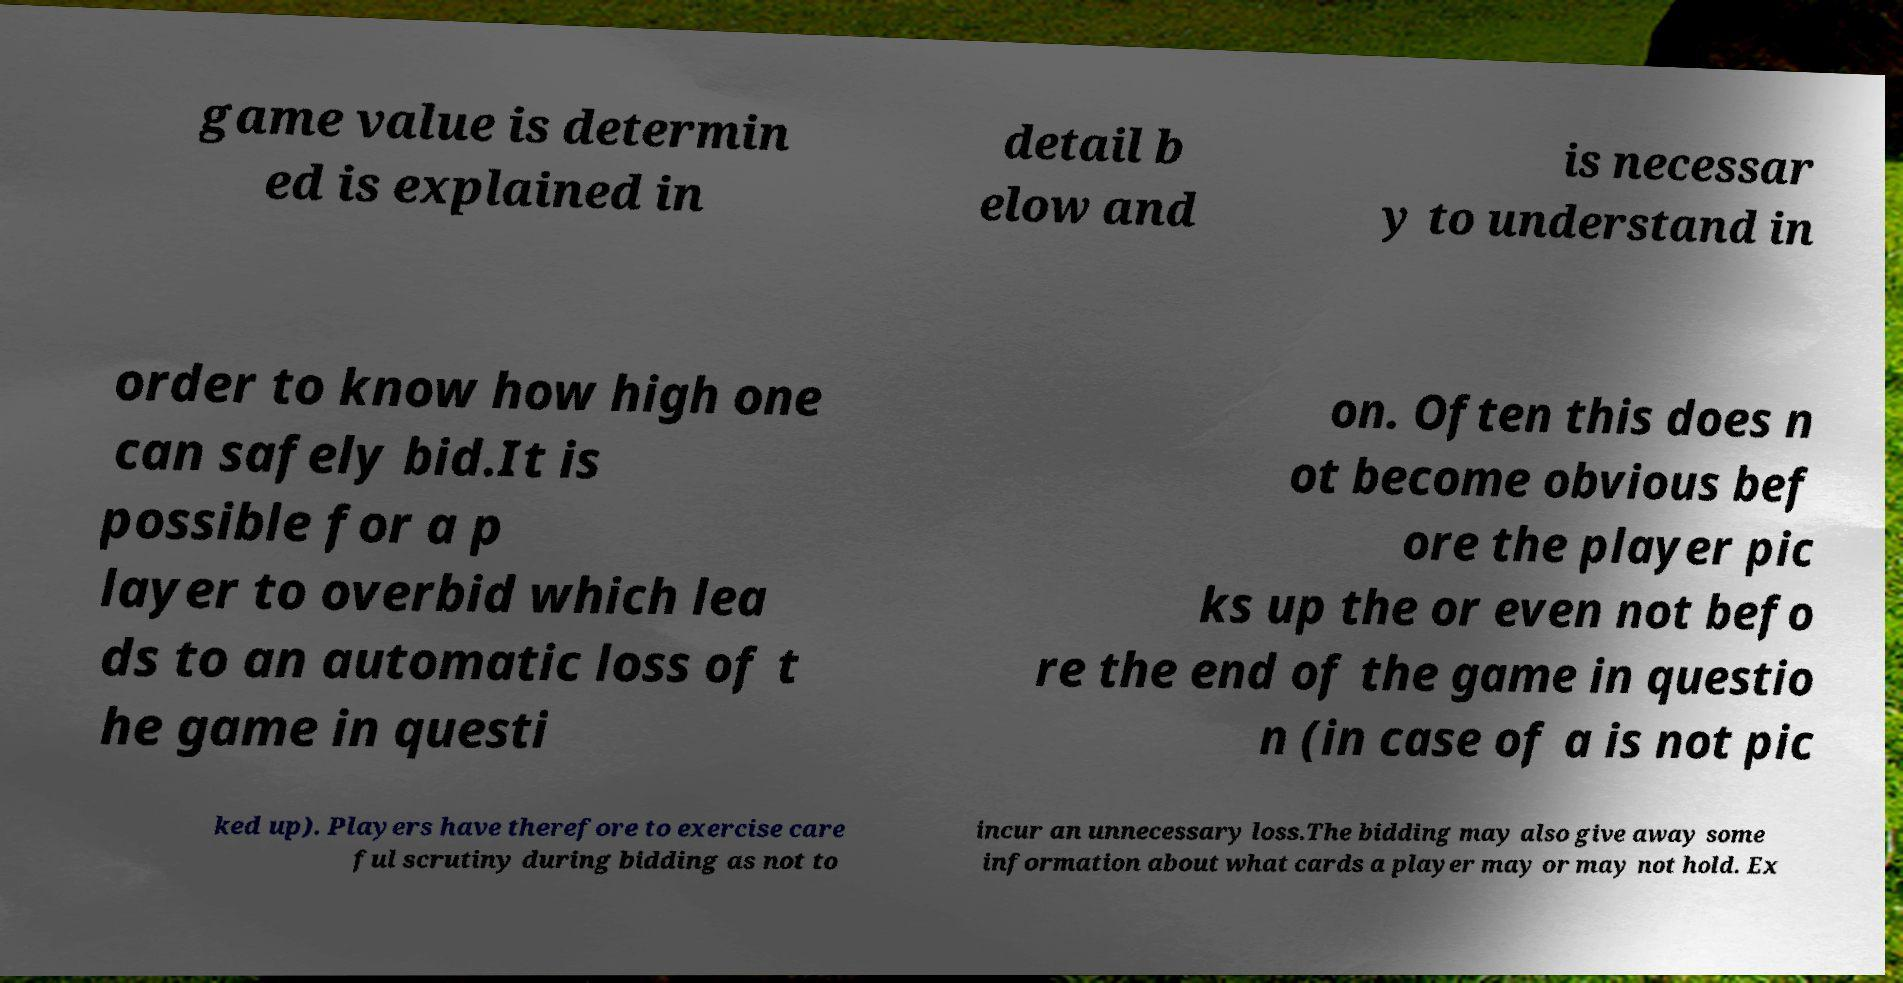Please read and relay the text visible in this image. What does it say? game value is determin ed is explained in detail b elow and is necessar y to understand in order to know how high one can safely bid.It is possible for a p layer to overbid which lea ds to an automatic loss of t he game in questi on. Often this does n ot become obvious bef ore the player pic ks up the or even not befo re the end of the game in questio n (in case of a is not pic ked up). Players have therefore to exercise care ful scrutiny during bidding as not to incur an unnecessary loss.The bidding may also give away some information about what cards a player may or may not hold. Ex 